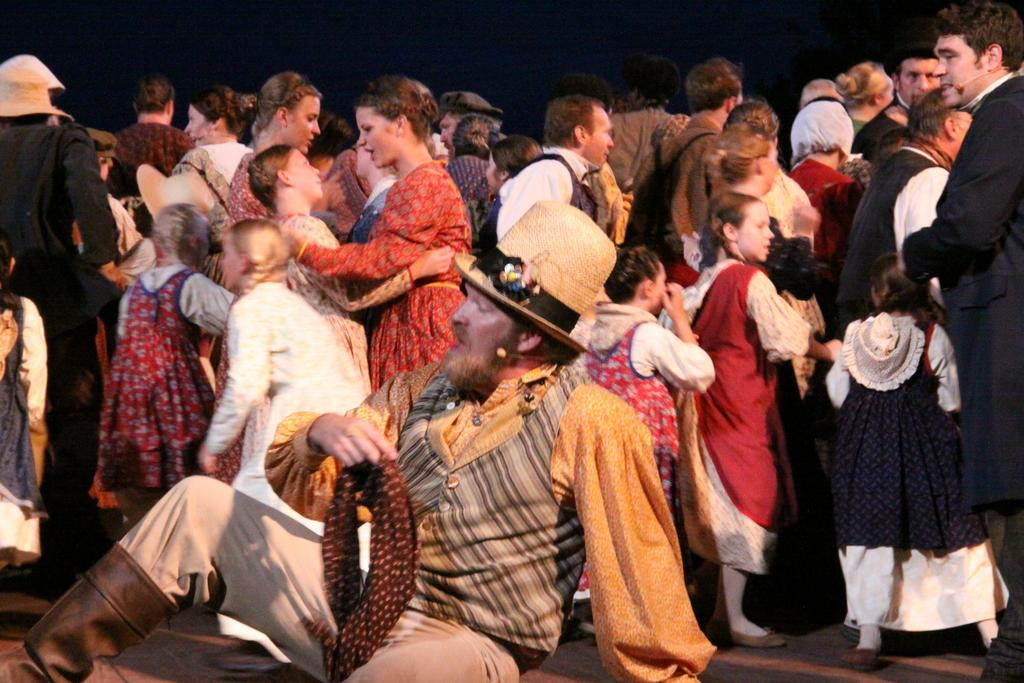How many people are in the image? There are people in the image. What is the position of one of the people in the image? One person is sitting. What is the sitting person wearing? The sitting person is wearing a hat. What can be observed about the background of the image? The background of the image is dark. How many dimes are visible on the hat of the sitting person in the image? There are no dimes visible on the hat of the sitting person in the image. What type of competition is taking place in the image? There is no competition present in the image. 